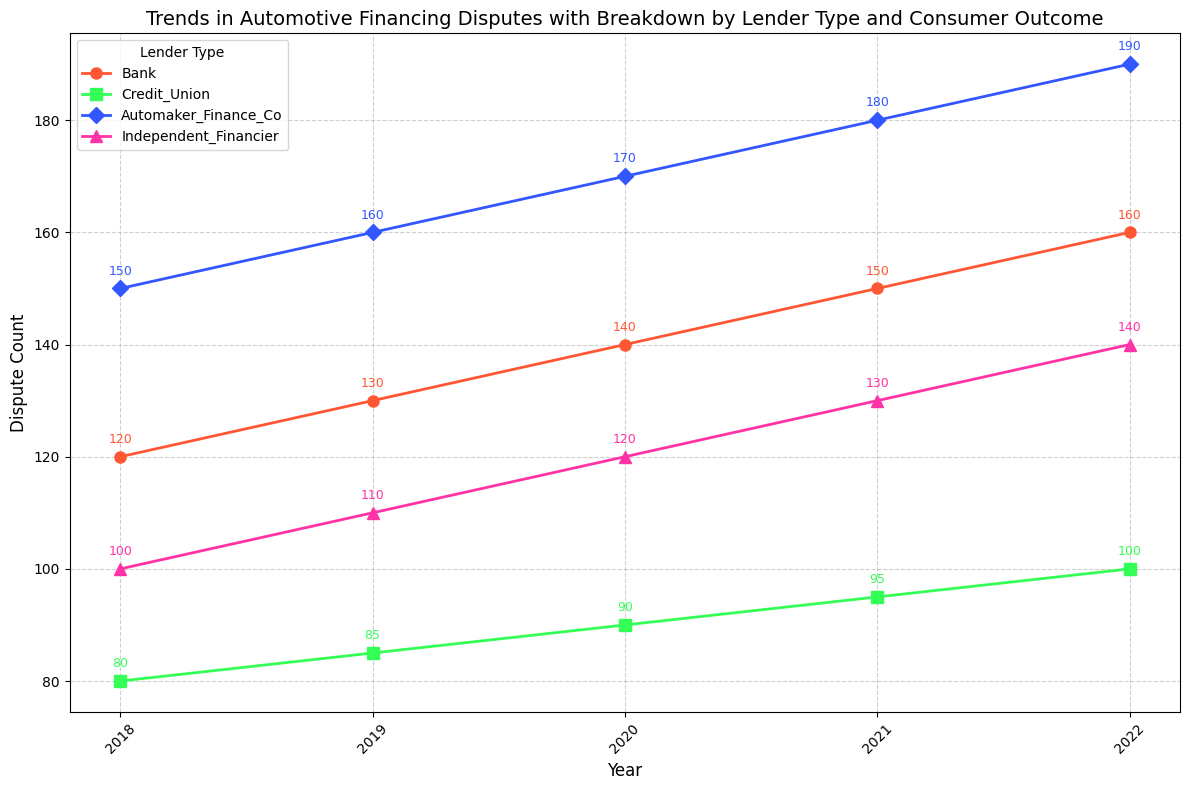What's the trend of dispute counts for Automaker Finance Companies from 2018 to 2022? We analyze the line representing Automaker Finance Companies (blue color). The dispute counts increase every year from 150 in 2018 to 190 in 2022.
Answer: Increasing Which lender type had the highest dispute count in 2022? We check which line reaches the highest value in 2022. The line for Automaker Finance Companies (blue color) reaches 190 disputes, which is the highest.
Answer: Automaker Finance Companies Among independent financiers, did dispute counts increase or decrease from 2018 to 2022? We observe the line for independent financiers (pink color) and see that dispute counts increase from 100 in 2018 to 140 in 2022.
Answer: Increase How many total disputes were reported by credit unions between 2018 and 2022? We sum up the dispute counts for Credit Unions (green color) across the years: 80 (2018) + 85 (2019) + 90 (2020) + 95 (2021) + 100 (2022) which equals 450 disputes.
Answer: 450 Compare consumer favorable outcomes in 2019 for Banks and Automaker Finance Companies. Which had more favorable outcomes, and by how much? Banks had 65 favorable outcomes, and Automaker Finance Companies had 75 favorable outcomes in 2019. Automaker Finance Companies had 75 - 65 = 10 more favorable outcomes.
Answer: Automaker Finance Companies by 10 What is the average number of disputes reported by Banks from 2018 to 2022? We first sum the dispute counts for Banks: 120 (2018) + 130 (2019) + 140 (2020) + 150 (2021) + 160 (2022) = 700. The average is 700/5 = 140 disputes.
Answer: 140 In which year did credit unions experience the largest increase in dispute counts compared to the previous year? By comparing year-on-year differences in dispute counts for Credit Unions (green color): 
2019-2018: 85 - 80 = 5,
2020-2019: 90 - 85 = 5,
2021-2020: 95 - 90 = 5,
2022-2021: 100 - 95 = 5.
The increase is constant, so no year had a larger increase than others.
Answer: No year had a larger increase Which year had the highest total dispute count for all lender types combined? Summing the dispute counts for each year:
2018: 120 + 80 + 150 + 100 = 450,
2019: 130 + 85 + 160 + 110 = 485,
2020: 140 + 90 + 170 + 120 = 520,
2021: 150 + 95 + 180 + 130 = 555,
2022: 160 + 100 + 190 + 140 = 590.
2022 had the highest total dispute count of 590.
Answer: 2022 